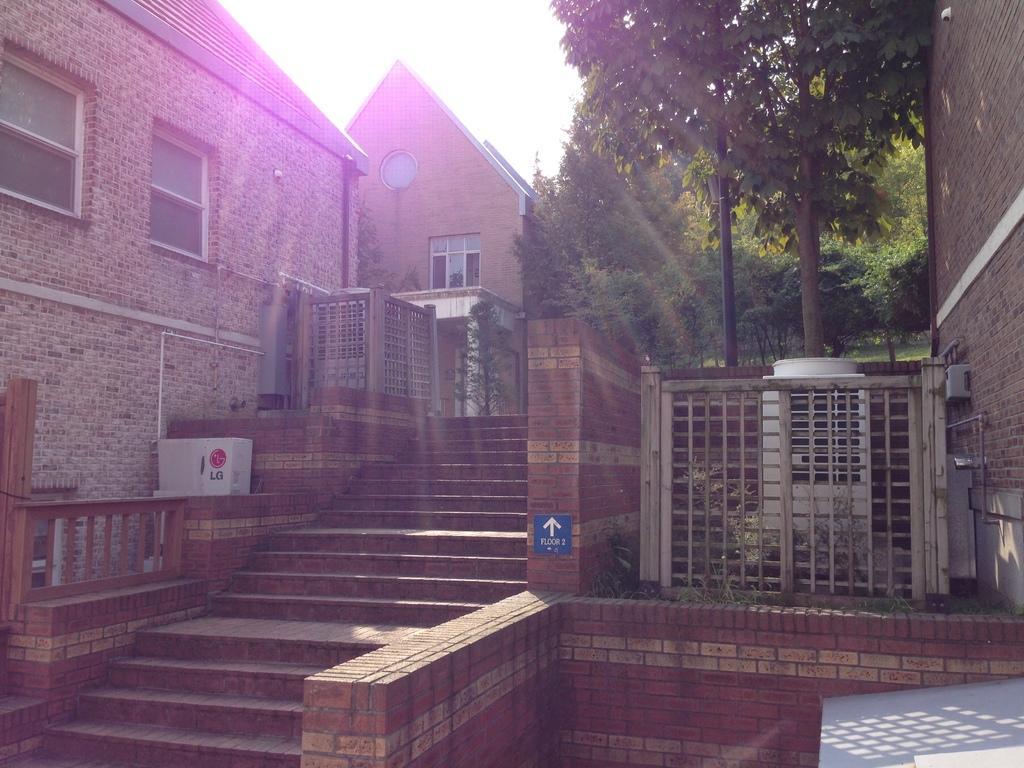Could you give a brief overview of what you see in this image? In this image we can see a building. There are many trees in the image. There are few objects in the image. There is a board on the wall. We can see the sky in the image. 